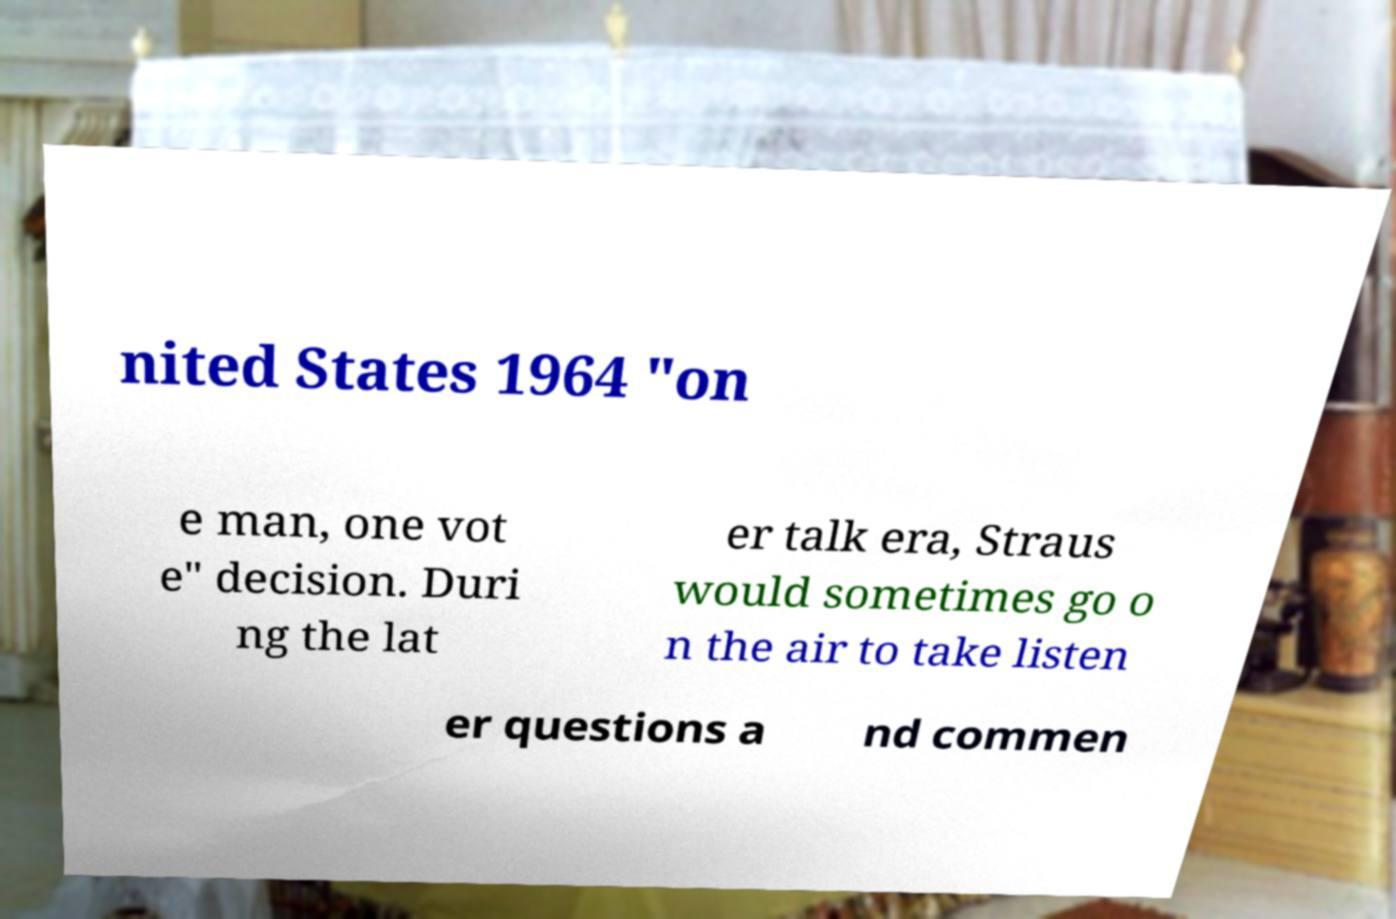For documentation purposes, I need the text within this image transcribed. Could you provide that? nited States 1964 "on e man, one vot e" decision. Duri ng the lat er talk era, Straus would sometimes go o n the air to take listen er questions a nd commen 